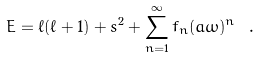Convert formula to latex. <formula><loc_0><loc_0><loc_500><loc_500>E = \ell ( \ell + 1 ) + s ^ { 2 } + \sum _ { n = 1 } ^ { \infty } f _ { n } ( a \omega ) ^ { n } \ .</formula> 